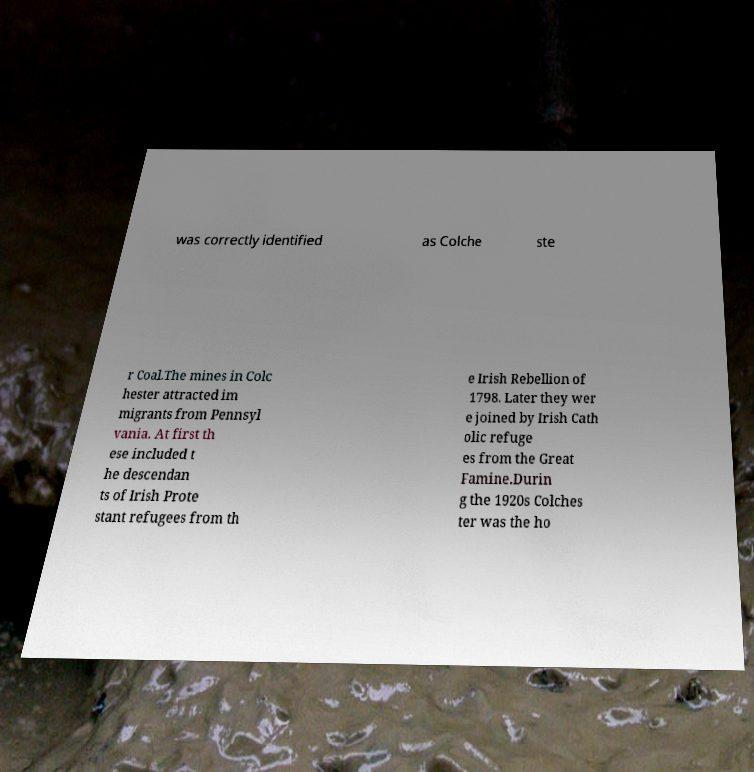What messages or text are displayed in this image? I need them in a readable, typed format. was correctly identified as Colche ste r Coal.The mines in Colc hester attracted im migrants from Pennsyl vania. At first th ese included t he descendan ts of Irish Prote stant refugees from th e Irish Rebellion of 1798. Later they wer e joined by Irish Cath olic refuge es from the Great Famine.Durin g the 1920s Colches ter was the ho 